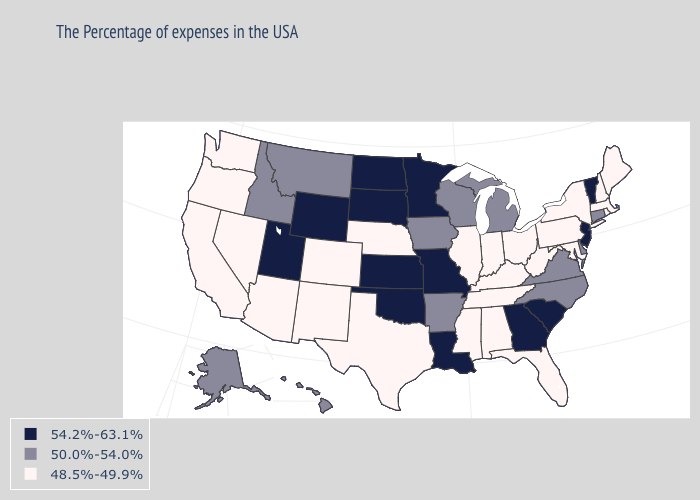Name the states that have a value in the range 54.2%-63.1%?
Quick response, please. Vermont, New Jersey, South Carolina, Georgia, Louisiana, Missouri, Minnesota, Kansas, Oklahoma, South Dakota, North Dakota, Wyoming, Utah. How many symbols are there in the legend?
Give a very brief answer. 3. Does New Hampshire have the same value as Idaho?
Concise answer only. No. Does Michigan have a lower value than South Dakota?
Short answer required. Yes. What is the value of Maine?
Be succinct. 48.5%-49.9%. Which states have the lowest value in the USA?
Concise answer only. Maine, Massachusetts, Rhode Island, New Hampshire, New York, Maryland, Pennsylvania, West Virginia, Ohio, Florida, Kentucky, Indiana, Alabama, Tennessee, Illinois, Mississippi, Nebraska, Texas, Colorado, New Mexico, Arizona, Nevada, California, Washington, Oregon. Which states hav the highest value in the MidWest?
Write a very short answer. Missouri, Minnesota, Kansas, South Dakota, North Dakota. What is the lowest value in states that border Maine?
Be succinct. 48.5%-49.9%. Name the states that have a value in the range 48.5%-49.9%?
Short answer required. Maine, Massachusetts, Rhode Island, New Hampshire, New York, Maryland, Pennsylvania, West Virginia, Ohio, Florida, Kentucky, Indiana, Alabama, Tennessee, Illinois, Mississippi, Nebraska, Texas, Colorado, New Mexico, Arizona, Nevada, California, Washington, Oregon. What is the highest value in the MidWest ?
Give a very brief answer. 54.2%-63.1%. What is the highest value in the USA?
Quick response, please. 54.2%-63.1%. Does Iowa have the lowest value in the USA?
Concise answer only. No. What is the value of Virginia?
Keep it brief. 50.0%-54.0%. Which states hav the highest value in the West?
Be succinct. Wyoming, Utah. 